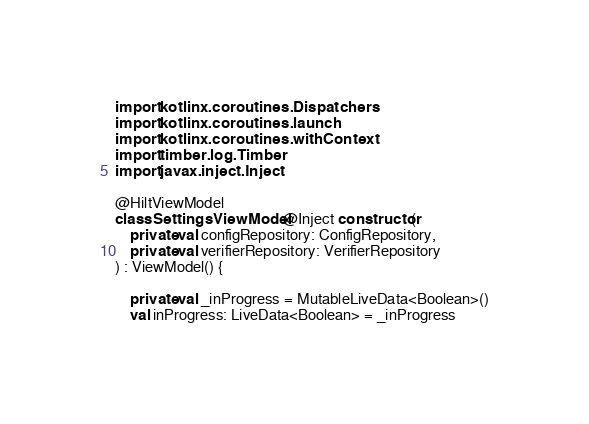Convert code to text. <code><loc_0><loc_0><loc_500><loc_500><_Kotlin_>import kotlinx.coroutines.Dispatchers
import kotlinx.coroutines.launch
import kotlinx.coroutines.withContext
import timber.log.Timber
import javax.inject.Inject

@HiltViewModel
class SettingsViewModel @Inject constructor(
    private val configRepository: ConfigRepository,
    private val verifierRepository: VerifierRepository
) : ViewModel() {

    private val _inProgress = MutableLiveData<Boolean>()
    val inProgress: LiveData<Boolean> = _inProgress</code> 